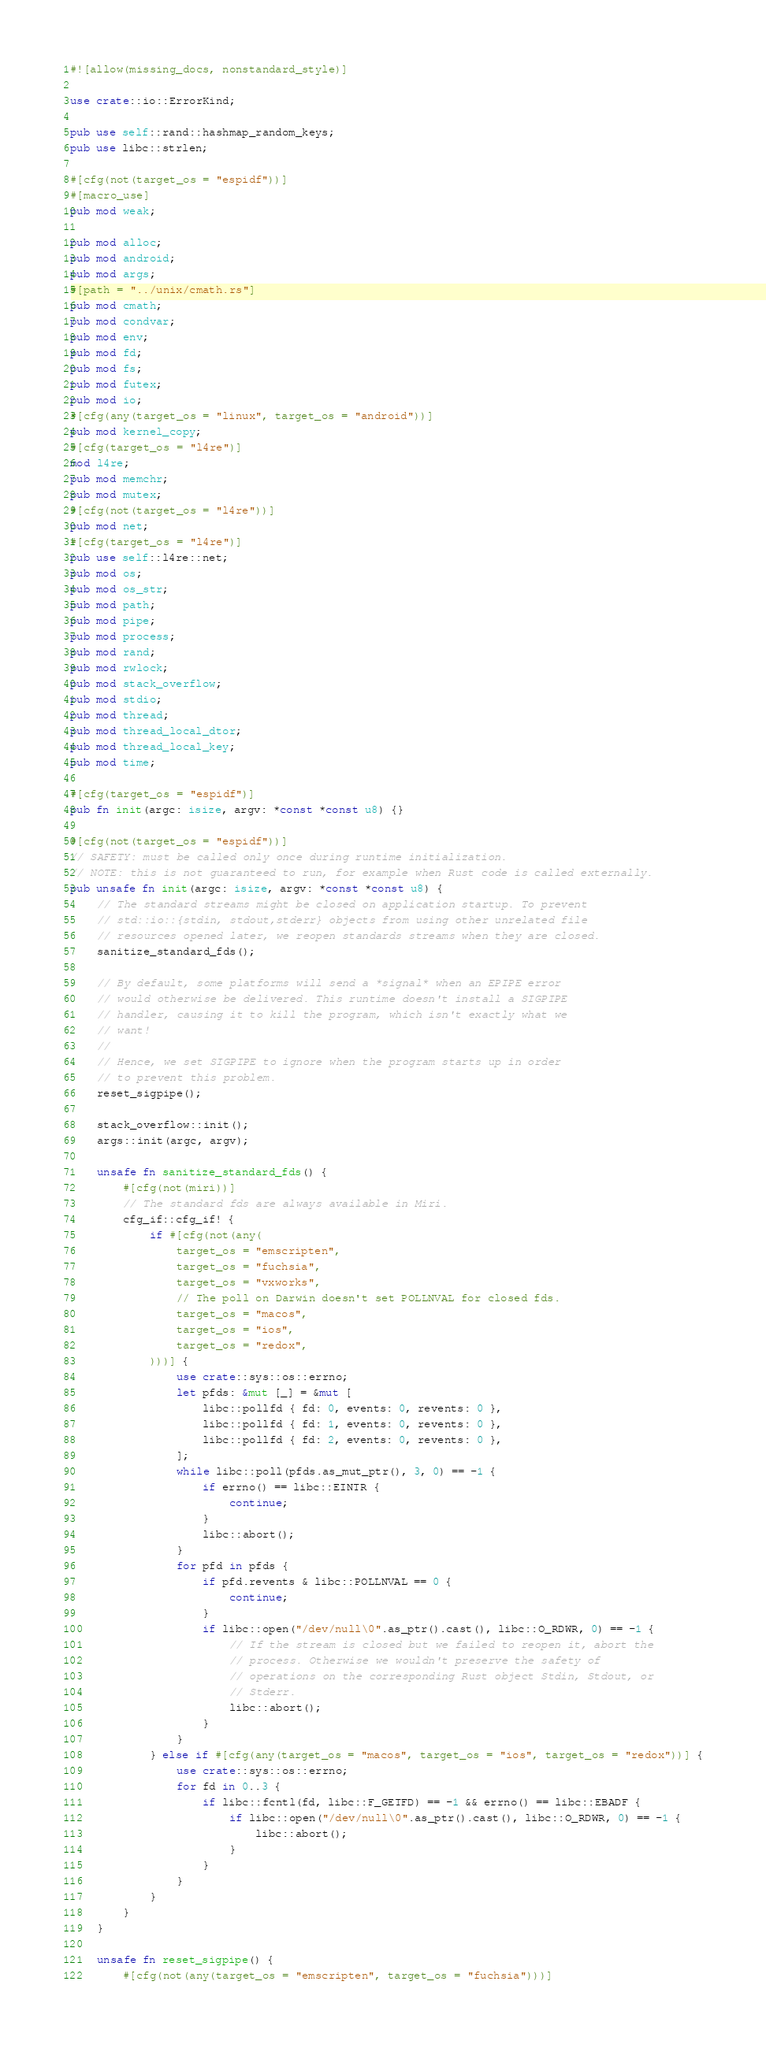<code> <loc_0><loc_0><loc_500><loc_500><_Rust_>#![allow(missing_docs, nonstandard_style)]

use crate::io::ErrorKind;

pub use self::rand::hashmap_random_keys;
pub use libc::strlen;

#[cfg(not(target_os = "espidf"))]
#[macro_use]
pub mod weak;

pub mod alloc;
pub mod android;
pub mod args;
#[path = "../unix/cmath.rs"]
pub mod cmath;
pub mod condvar;
pub mod env;
pub mod fd;
pub mod fs;
pub mod futex;
pub mod io;
#[cfg(any(target_os = "linux", target_os = "android"))]
pub mod kernel_copy;
#[cfg(target_os = "l4re")]
mod l4re;
pub mod memchr;
pub mod mutex;
#[cfg(not(target_os = "l4re"))]
pub mod net;
#[cfg(target_os = "l4re")]
pub use self::l4re::net;
pub mod os;
pub mod os_str;
pub mod path;
pub mod pipe;
pub mod process;
pub mod rand;
pub mod rwlock;
pub mod stack_overflow;
pub mod stdio;
pub mod thread;
pub mod thread_local_dtor;
pub mod thread_local_key;
pub mod time;

#[cfg(target_os = "espidf")]
pub fn init(argc: isize, argv: *const *const u8) {}

#[cfg(not(target_os = "espidf"))]
// SAFETY: must be called only once during runtime initialization.
// NOTE: this is not guaranteed to run, for example when Rust code is called externally.
pub unsafe fn init(argc: isize, argv: *const *const u8) {
    // The standard streams might be closed on application startup. To prevent
    // std::io::{stdin, stdout,stderr} objects from using other unrelated file
    // resources opened later, we reopen standards streams when they are closed.
    sanitize_standard_fds();

    // By default, some platforms will send a *signal* when an EPIPE error
    // would otherwise be delivered. This runtime doesn't install a SIGPIPE
    // handler, causing it to kill the program, which isn't exactly what we
    // want!
    //
    // Hence, we set SIGPIPE to ignore when the program starts up in order
    // to prevent this problem.
    reset_sigpipe();

    stack_overflow::init();
    args::init(argc, argv);

    unsafe fn sanitize_standard_fds() {
        #[cfg(not(miri))]
        // The standard fds are always available in Miri.
        cfg_if::cfg_if! {
            if #[cfg(not(any(
                target_os = "emscripten",
                target_os = "fuchsia",
                target_os = "vxworks",
                // The poll on Darwin doesn't set POLLNVAL for closed fds.
                target_os = "macos",
                target_os = "ios",
                target_os = "redox",
            )))] {
                use crate::sys::os::errno;
                let pfds: &mut [_] = &mut [
                    libc::pollfd { fd: 0, events: 0, revents: 0 },
                    libc::pollfd { fd: 1, events: 0, revents: 0 },
                    libc::pollfd { fd: 2, events: 0, revents: 0 },
                ];
                while libc::poll(pfds.as_mut_ptr(), 3, 0) == -1 {
                    if errno() == libc::EINTR {
                        continue;
                    }
                    libc::abort();
                }
                for pfd in pfds {
                    if pfd.revents & libc::POLLNVAL == 0 {
                        continue;
                    }
                    if libc::open("/dev/null\0".as_ptr().cast(), libc::O_RDWR, 0) == -1 {
                        // If the stream is closed but we failed to reopen it, abort the
                        // process. Otherwise we wouldn't preserve the safety of
                        // operations on the corresponding Rust object Stdin, Stdout, or
                        // Stderr.
                        libc::abort();
                    }
                }
            } else if #[cfg(any(target_os = "macos", target_os = "ios", target_os = "redox"))] {
                use crate::sys::os::errno;
                for fd in 0..3 {
                    if libc::fcntl(fd, libc::F_GETFD) == -1 && errno() == libc::EBADF {
                        if libc::open("/dev/null\0".as_ptr().cast(), libc::O_RDWR, 0) == -1 {
                            libc::abort();
                        }
                    }
                }
            }
        }
    }

    unsafe fn reset_sigpipe() {
        #[cfg(not(any(target_os = "emscripten", target_os = "fuchsia")))]</code> 